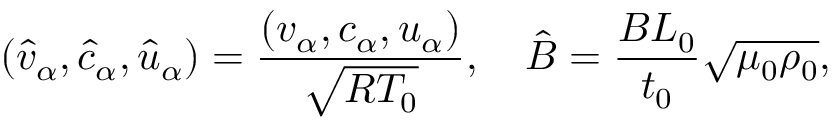Convert formula to latex. <formula><loc_0><loc_0><loc_500><loc_500>\left ( { { { \hat { v } } _ { \alpha } } , { { \hat { c } } _ { \alpha } } , { { \hat { u } } _ { \alpha } } } \right ) = \frac { { \left ( { { v _ { \alpha } } , { c _ { \alpha } } , { u _ { \alpha } } } \right ) } } { { { \sqrt { R { T _ { 0 } } } } } } , \quad \hat { B } = \frac { { B { L _ { 0 } } } } { { { t _ { 0 } } } } \sqrt { { \mu _ { 0 } } { \rho _ { 0 } } } ,</formula> 